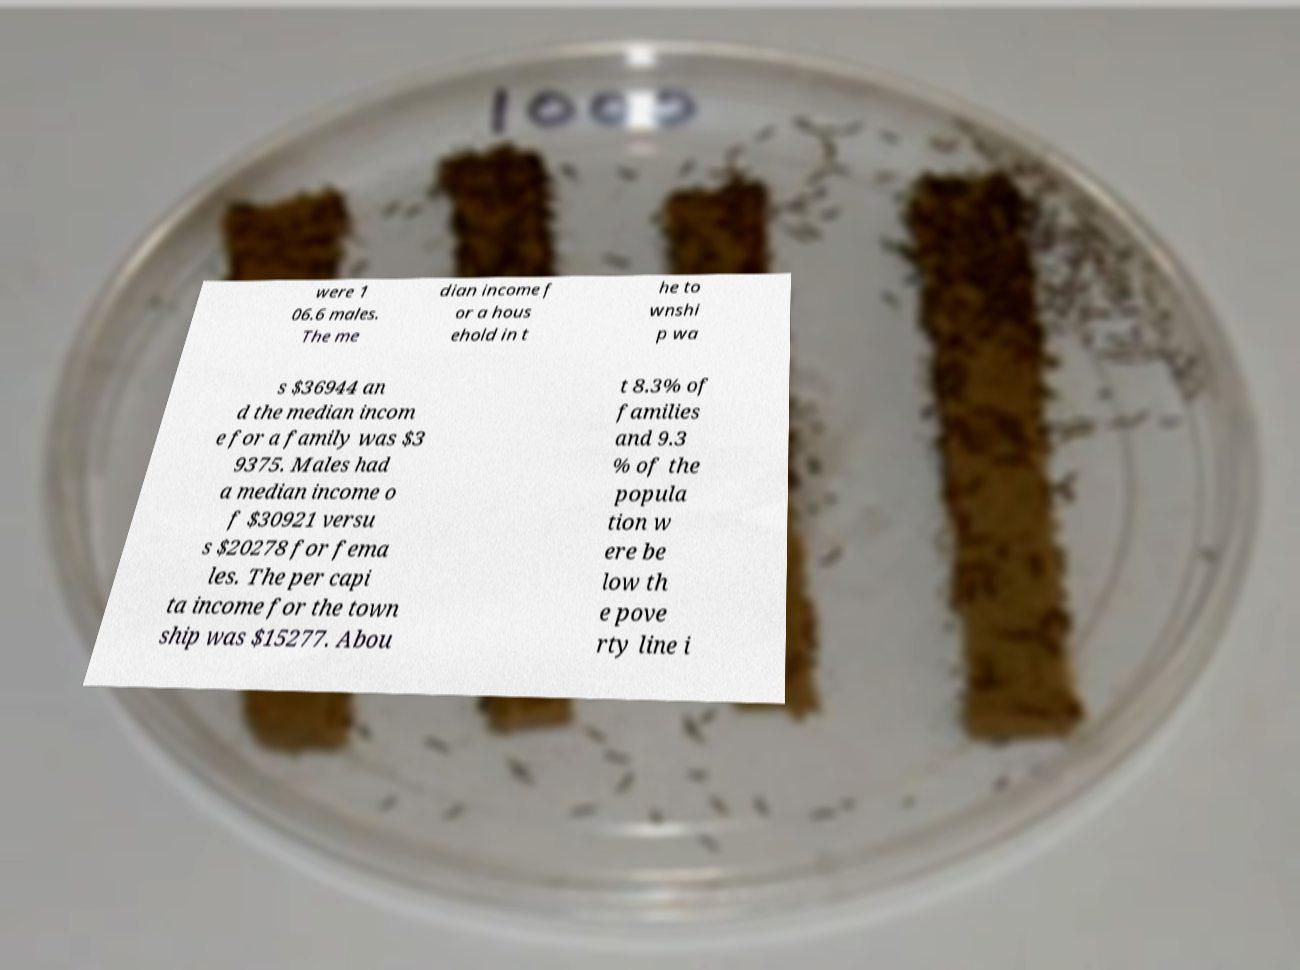There's text embedded in this image that I need extracted. Can you transcribe it verbatim? were 1 06.6 males. The me dian income f or a hous ehold in t he to wnshi p wa s $36944 an d the median incom e for a family was $3 9375. Males had a median income o f $30921 versu s $20278 for fema les. The per capi ta income for the town ship was $15277. Abou t 8.3% of families and 9.3 % of the popula tion w ere be low th e pove rty line i 